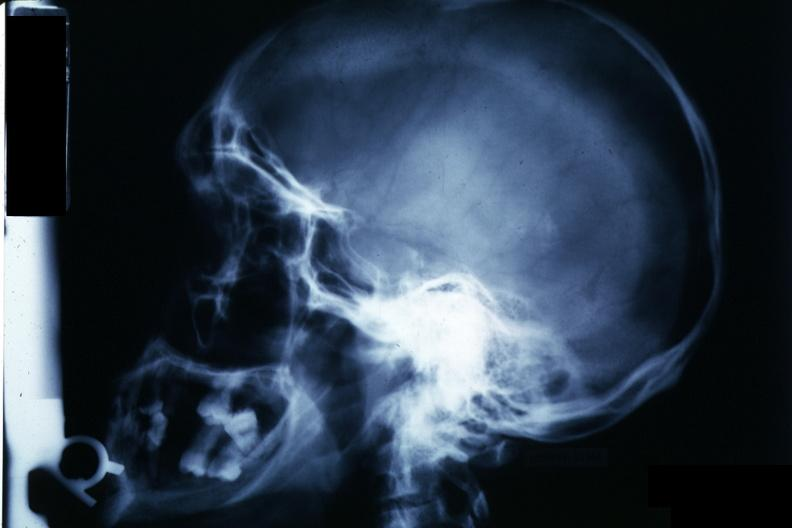s chromophobe adenoma present?
Answer the question using a single word or phrase. Yes 